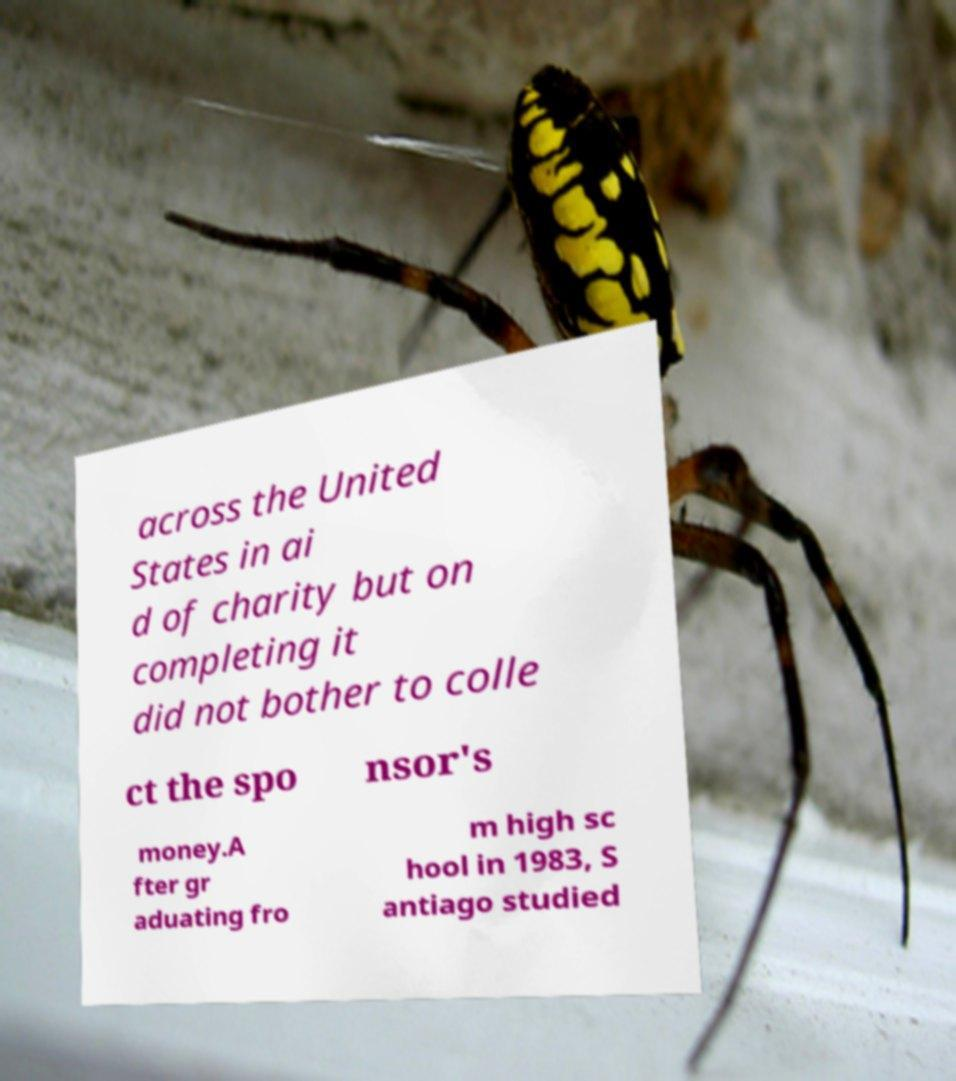Please identify and transcribe the text found in this image. across the United States in ai d of charity but on completing it did not bother to colle ct the spo nsor's money.A fter gr aduating fro m high sc hool in 1983, S antiago studied 